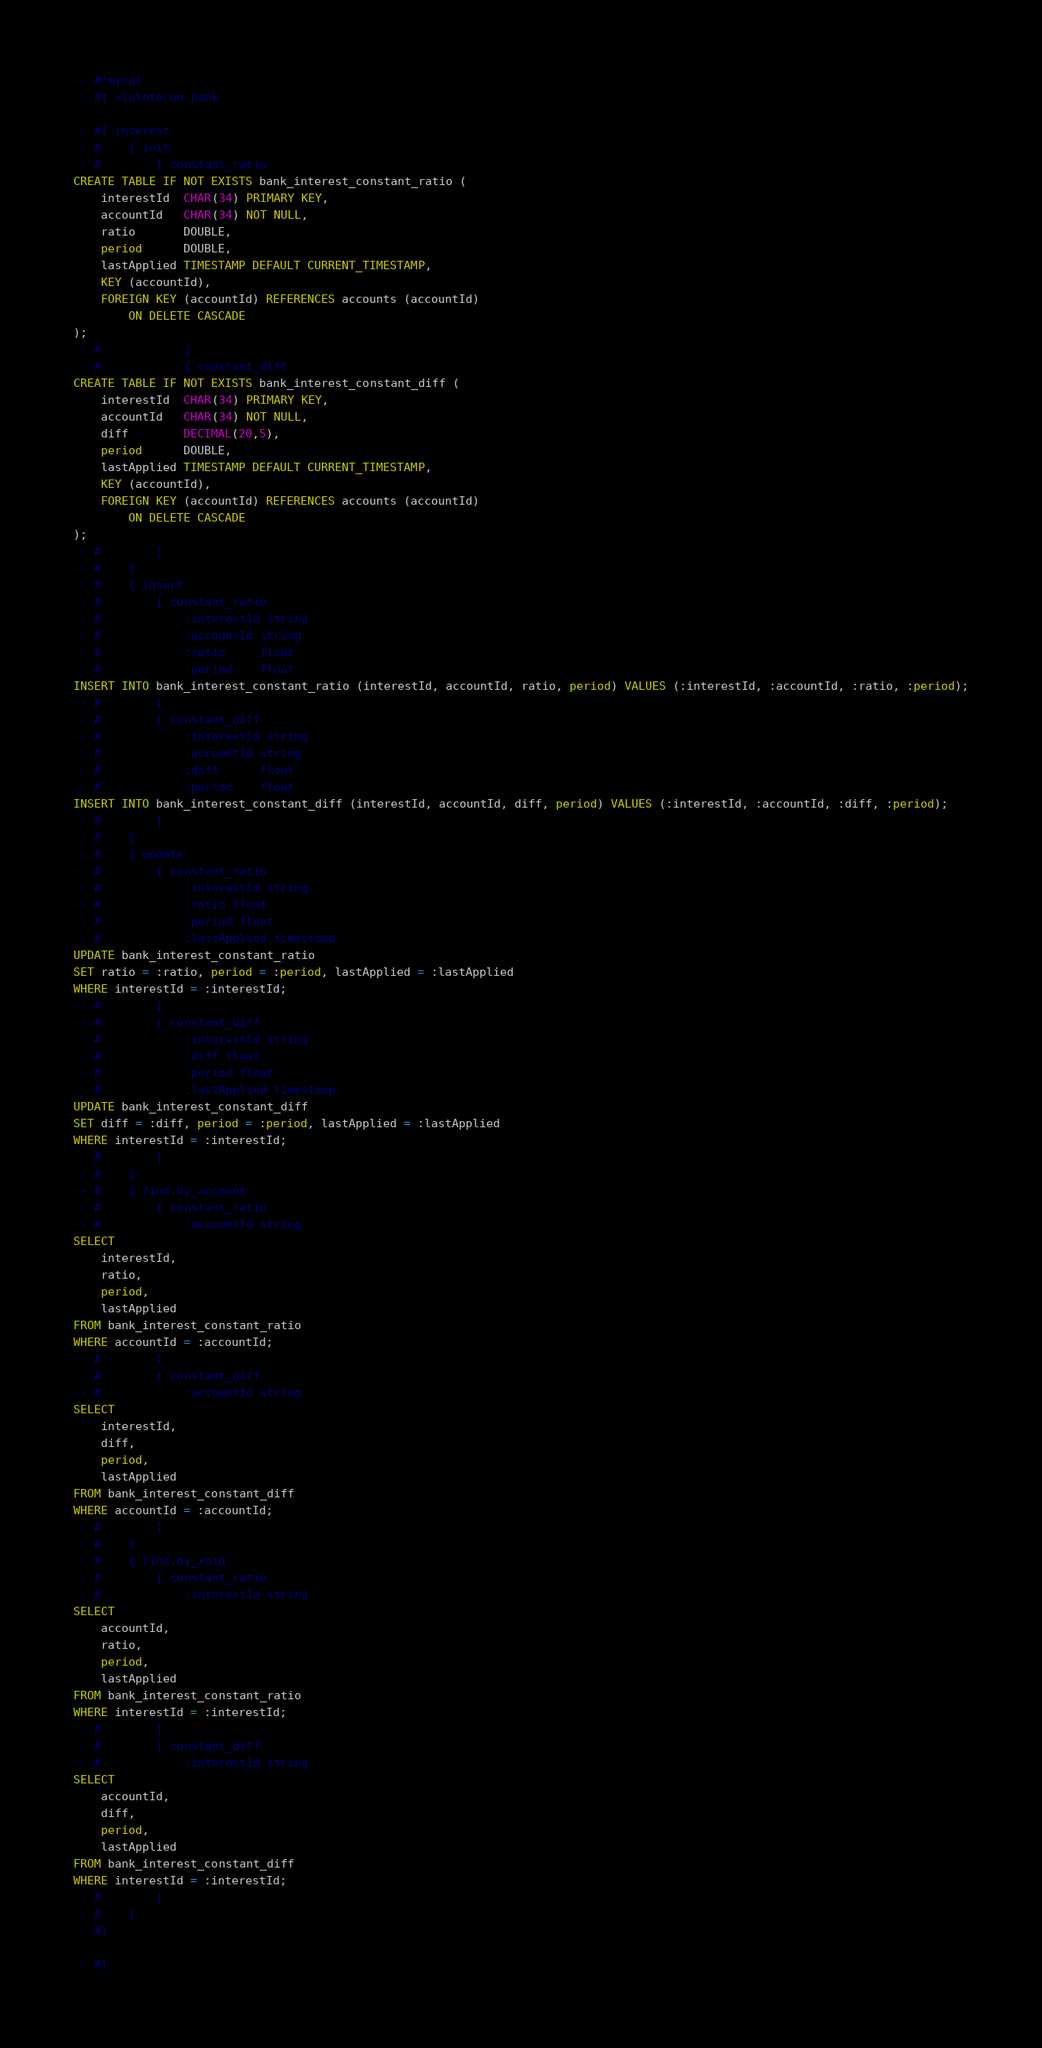Convert code to text. <code><loc_0><loc_0><loc_500><loc_500><_SQL_>-- #!mysql
-- #{ xialotecon.bank

-- #{ interest
-- #    { init
-- #        { constant_ratio
CREATE TABLE IF NOT EXISTS bank_interest_constant_ratio (
	interestId  CHAR(34) PRIMARY KEY,
	accountId   CHAR(34) NOT NULL,
	ratio       DOUBLE,
	period      DOUBLE,
	lastApplied TIMESTAMP DEFAULT CURRENT_TIMESTAMP,
	KEY (accountId),
	FOREIGN KEY (accountId) REFERENCES accounts (accountId)
		ON DELETE CASCADE
);
-- #            }
-- #            { constant_diff
CREATE TABLE IF NOT EXISTS bank_interest_constant_diff (
	interestId  CHAR(34) PRIMARY KEY,
	accountId   CHAR(34) NOT NULL,
	diff        DECIMAL(20,5),
	period      DOUBLE,
	lastApplied TIMESTAMP DEFAULT CURRENT_TIMESTAMP,
	KEY (accountId),
	FOREIGN KEY (accountId) REFERENCES accounts (accountId)
		ON DELETE CASCADE
);
-- #        }
-- #    }
-- #    { insert
-- #        { constant_ratio
-- #            :interestId string
-- #            :accountId string
-- #            :ratio     float
-- #            :period    float
INSERT INTO bank_interest_constant_ratio (interestId, accountId, ratio, period) VALUES (:interestId, :accountId, :ratio, :period);
-- #        }
-- #        { constant_diff
-- #            :interestId string
-- #            :accountId string
-- #            :diff      float
-- #            :period    float
INSERT INTO bank_interest_constant_diff (interestId, accountId, diff, period) VALUES (:interestId, :accountId, :diff, :period);
-- #        }
-- #    }
-- #    { update
-- #        { constant_ratio
-- #            :interestId string
-- #            :ratio float
-- #            :period float
-- #            :lastApplied timestamp
UPDATE bank_interest_constant_ratio
SET ratio = :ratio, period = :period, lastApplied = :lastApplied
WHERE interestId = :interestId;
-- #        }
-- #        { constant_diff
-- #            :interestId string
-- #            :diff float
-- #            :period float
-- #            :lastApplied timestamp
UPDATE bank_interest_constant_diff
SET diff = :diff, period = :period, lastApplied = :lastApplied
WHERE interestId = :interestId;
-- #        }
-- #    }
-- #    { find.by_account
-- #        { constant_ratio
-- #            :accountId string
SELECT
	interestId,
	ratio,
	period,
	lastApplied
FROM bank_interest_constant_ratio
WHERE accountId = :accountId;
-- #        }
-- #        { constant_diff
-- #            :accountId string
SELECT
	interestId,
	diff,
	period,
	lastApplied
FROM bank_interest_constant_diff
WHERE accountId = :accountId;
-- #        }
-- #    }
-- #    { find.by_xoid
-- #        { constant_ratio
-- #            :interestId string
SELECT
	accountId,
	ratio,
	period,
	lastApplied
FROM bank_interest_constant_ratio
WHERE interestId = :interestId;
-- #        }
-- #        { constant_diff
-- #            :interestId string
SELECT
	accountId,
	diff,
	period,
	lastApplied
FROM bank_interest_constant_diff
WHERE interestId = :interestId;
-- #        }
-- #    }
-- #}

-- #}
</code> 